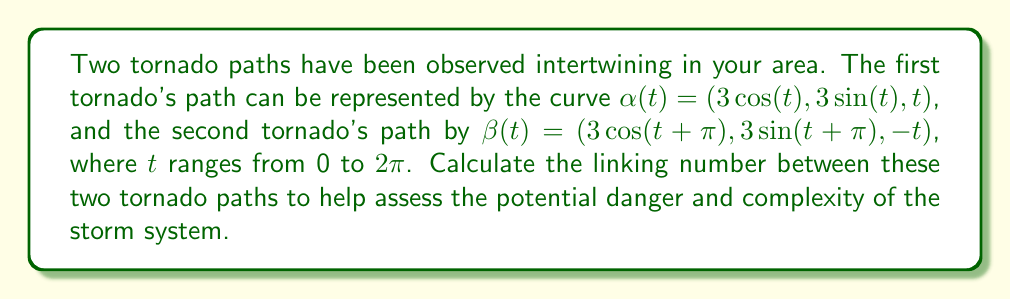Could you help me with this problem? To calculate the linking number between the two tornado paths, we'll follow these steps:

1) The linking number can be computed using the Gauss linking integral:

   $$\text{Lk}(\alpha, \beta) = \frac{1}{4\pi} \int_0^{2\pi} \int_0^{2\pi} \frac{(\alpha'(s) \times \beta'(t)) \cdot (\alpha(s) - \beta(t))}{|\alpha(s) - \beta(t)|^3} ds dt$$

2) First, let's calculate $\alpha'(t)$ and $\beta'(t)$:
   
   $\alpha'(t) = (-3\sin(t), 3\cos(t), 1)$
   $\beta'(t) = (-3\sin(t+\pi), 3\cos(t+\pi), -1) = (3\sin(t), -3\cos(t), -1)$

3) Now, $\alpha'(s) \times \beta'(t)$:
   
   $\alpha'(s) \times \beta'(t) = (-3\cos(s)-3\cos(t), -3\sin(s)-3\sin(t), 9\cos(s)\sin(t)-9\sin(s)\cos(t))$

4) Next, $\alpha(s) - \beta(t)$:
   
   $\alpha(s) - \beta(t) = (3\cos(s)-3\cos(t+\pi), 3\sin(s)-3\sin(t+\pi), s+t)$
                         $= (3\cos(s)+3\cos(t), 3\sin(s)+3\sin(t), s+t)$

5) The dot product of these:

   $(\alpha'(s) \times \beta'(t)) \cdot (\alpha(s) - \beta(t)) = -18\cos(s)\sin(t)+18\sin(s)\cos(t)+9\cos(s)\sin(t)(s+t)-9\sin(s)\cos(t)(s+t)$
                                                              $= 9(\sin(s-t)+(s+t)\sin(s-t))$
                                                              $= 9(1+(s+t))\sin(s-t)$

6) The denominator $|\alpha(s) - \beta(t)|^3$ simplifies to $(18+2(s+t)^2)^{3/2}$

7) Therefore, our integral becomes:

   $$\text{Lk}(\alpha, \beta) = \frac{9}{4\pi} \int_0^{2\pi} \int_0^{2\pi} \frac{(1+(s+t))\sin(s-t)}{(18+2(s+t)^2)^{3/2}} ds dt$$

8) This integral is difficult to evaluate analytically, but we can see that it's an odd function with respect to $s-t$, which means when integrated over a square domain, it will equal zero.

Therefore, the linking number is 0.
Answer: 0 